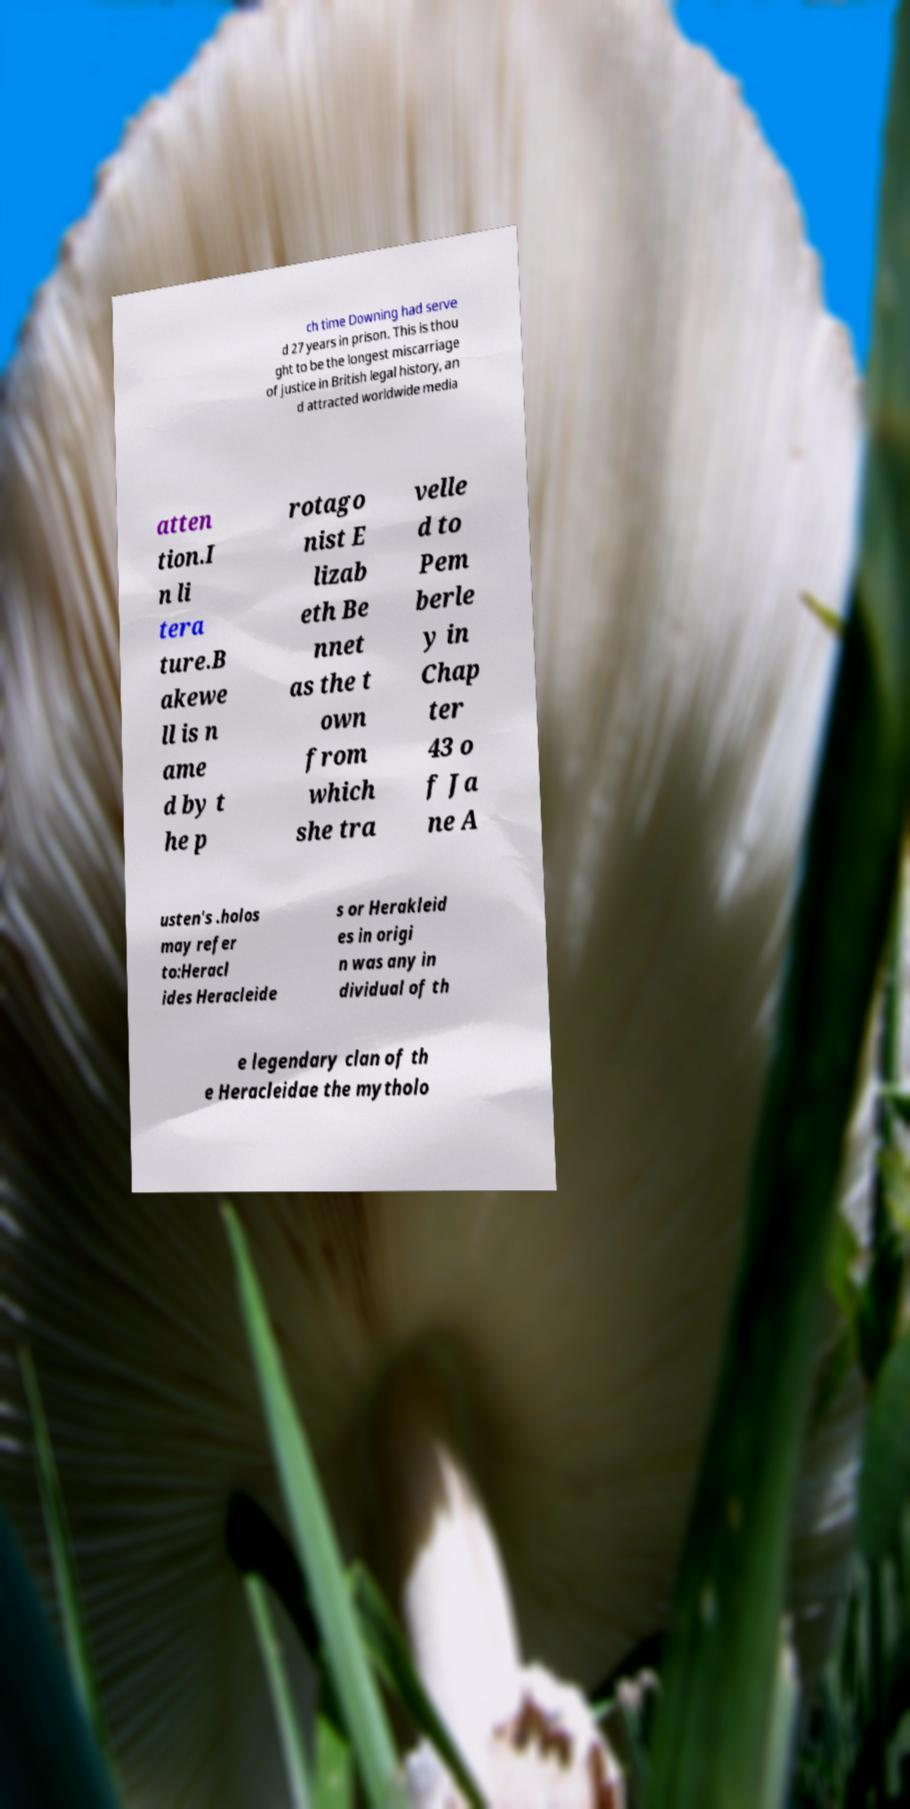Please read and relay the text visible in this image. What does it say? ch time Downing had serve d 27 years in prison. This is thou ght to be the longest miscarriage of justice in British legal history, an d attracted worldwide media atten tion.I n li tera ture.B akewe ll is n ame d by t he p rotago nist E lizab eth Be nnet as the t own from which she tra velle d to Pem berle y in Chap ter 43 o f Ja ne A usten's .holos may refer to:Heracl ides Heracleide s or Herakleid es in origi n was any in dividual of th e legendary clan of th e Heracleidae the mytholo 